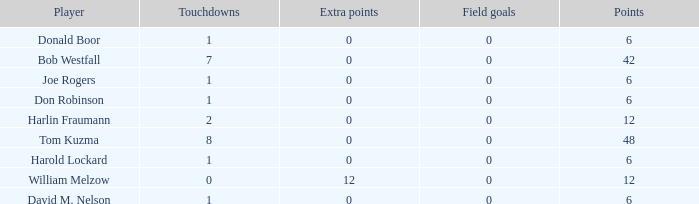Name the least touchdowns for joe rogers 1.0. 